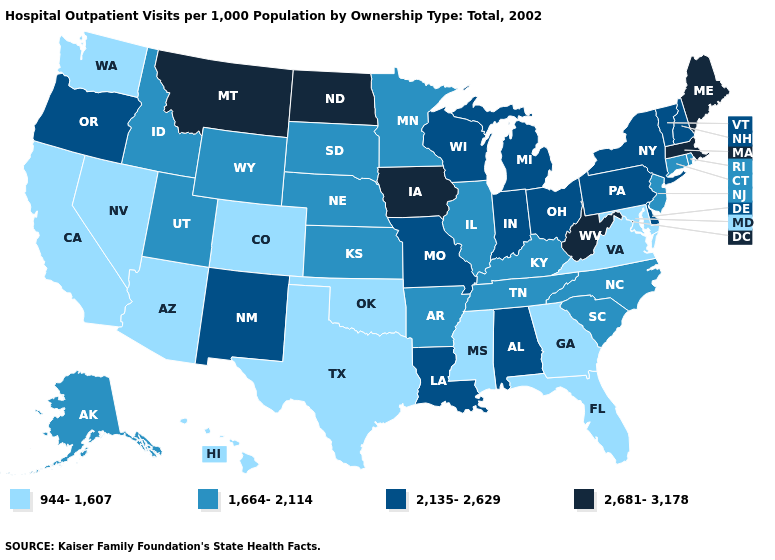What is the value of Vermont?
Concise answer only. 2,135-2,629. Does Michigan have the highest value in the USA?
Answer briefly. No. Among the states that border California , does Nevada have the highest value?
Give a very brief answer. No. Does Minnesota have a lower value than Arkansas?
Write a very short answer. No. Name the states that have a value in the range 2,681-3,178?
Be succinct. Iowa, Maine, Massachusetts, Montana, North Dakota, West Virginia. Which states have the highest value in the USA?
Quick response, please. Iowa, Maine, Massachusetts, Montana, North Dakota, West Virginia. What is the value of North Carolina?
Write a very short answer. 1,664-2,114. Does Massachusetts have the highest value in the Northeast?
Give a very brief answer. Yes. Does Delaware have a higher value than Minnesota?
Short answer required. Yes. Name the states that have a value in the range 944-1,607?
Answer briefly. Arizona, California, Colorado, Florida, Georgia, Hawaii, Maryland, Mississippi, Nevada, Oklahoma, Texas, Virginia, Washington. What is the lowest value in the USA?
Answer briefly. 944-1,607. What is the lowest value in the USA?
Concise answer only. 944-1,607. Does Delaware have a lower value than West Virginia?
Short answer required. Yes. What is the lowest value in the USA?
Give a very brief answer. 944-1,607. Name the states that have a value in the range 2,681-3,178?
Concise answer only. Iowa, Maine, Massachusetts, Montana, North Dakota, West Virginia. 